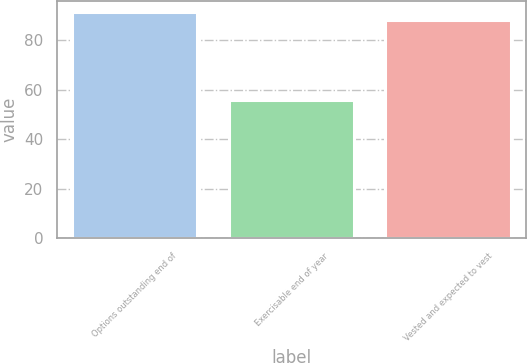Convert chart to OTSL. <chart><loc_0><loc_0><loc_500><loc_500><bar_chart><fcel>Options outstanding end of<fcel>Exercisable end of year<fcel>Vested and expected to vest<nl><fcel>91.3<fcel>56<fcel>88<nl></chart> 